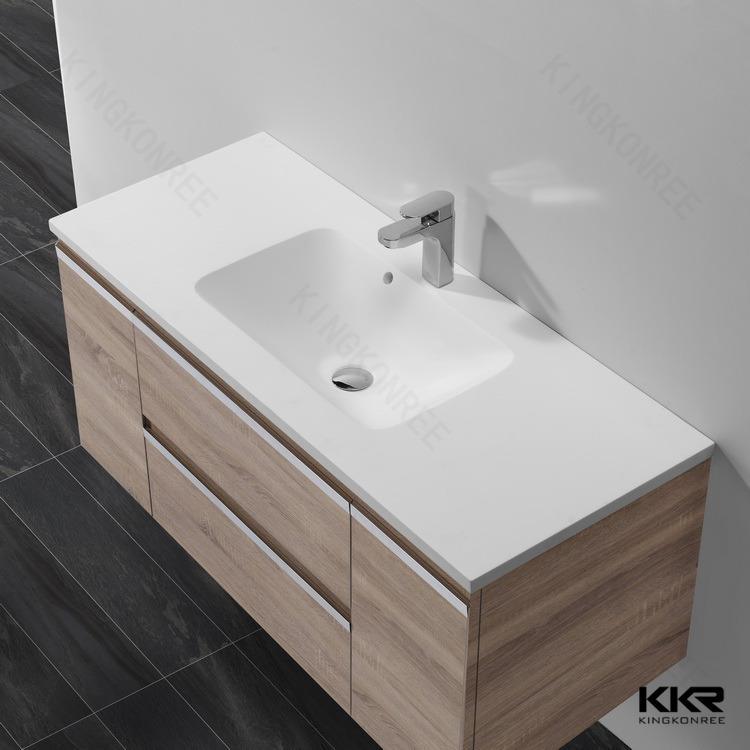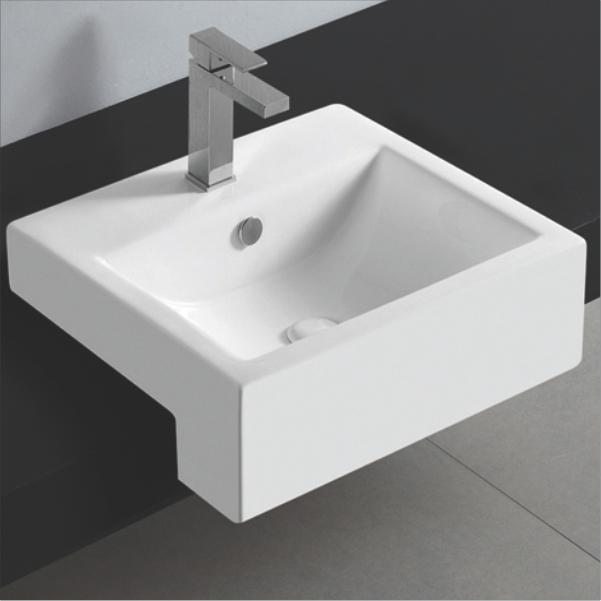The first image is the image on the left, the second image is the image on the right. For the images shown, is this caption "Each sink is rectangular" true? Answer yes or no. Yes. The first image is the image on the left, the second image is the image on the right. Analyze the images presented: Is the assertion "The left image shows one rectangular sink which is inset and has a wide counter, and the right image shows a sink that is more square and does not have a wide counter." valid? Answer yes or no. Yes. 